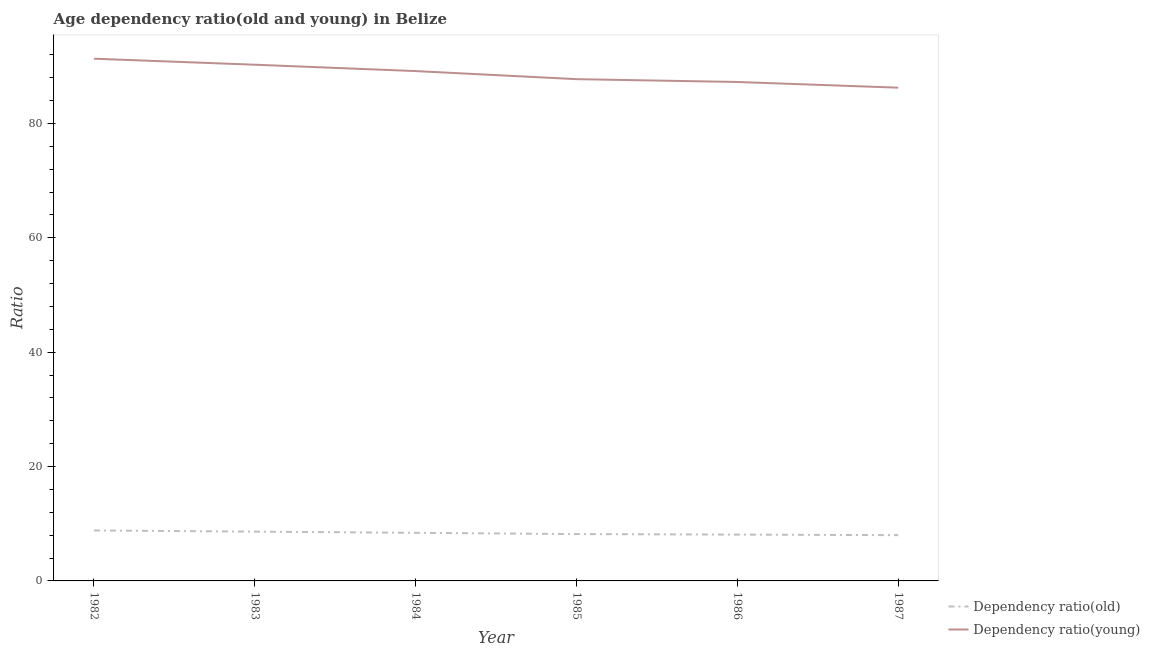How many different coloured lines are there?
Make the answer very short. 2. Does the line corresponding to age dependency ratio(old) intersect with the line corresponding to age dependency ratio(young)?
Offer a terse response. No. Is the number of lines equal to the number of legend labels?
Offer a terse response. Yes. What is the age dependency ratio(young) in 1982?
Give a very brief answer. 91.31. Across all years, what is the maximum age dependency ratio(old)?
Your response must be concise. 8.82. Across all years, what is the minimum age dependency ratio(young)?
Provide a short and direct response. 86.25. What is the total age dependency ratio(old) in the graph?
Provide a succinct answer. 50.15. What is the difference between the age dependency ratio(young) in 1982 and that in 1984?
Offer a terse response. 2.17. What is the difference between the age dependency ratio(young) in 1986 and the age dependency ratio(old) in 1987?
Ensure brevity in your answer.  79.23. What is the average age dependency ratio(young) per year?
Your answer should be very brief. 88.65. In the year 1982, what is the difference between the age dependency ratio(old) and age dependency ratio(young)?
Give a very brief answer. -82.49. What is the ratio of the age dependency ratio(young) in 1983 to that in 1985?
Offer a very short reply. 1.03. Is the age dependency ratio(young) in 1983 less than that in 1986?
Your answer should be very brief. No. Is the difference between the age dependency ratio(old) in 1983 and 1986 greater than the difference between the age dependency ratio(young) in 1983 and 1986?
Ensure brevity in your answer.  No. What is the difference between the highest and the second highest age dependency ratio(old)?
Ensure brevity in your answer.  0.2. What is the difference between the highest and the lowest age dependency ratio(old)?
Offer a terse response. 0.82. In how many years, is the age dependency ratio(young) greater than the average age dependency ratio(young) taken over all years?
Your answer should be compact. 3. How many lines are there?
Provide a succinct answer. 2. Are the values on the major ticks of Y-axis written in scientific E-notation?
Your response must be concise. No. Does the graph contain any zero values?
Provide a succinct answer. No. Where does the legend appear in the graph?
Offer a terse response. Bottom right. How many legend labels are there?
Ensure brevity in your answer.  2. What is the title of the graph?
Keep it short and to the point. Age dependency ratio(old and young) in Belize. What is the label or title of the Y-axis?
Provide a succinct answer. Ratio. What is the Ratio of Dependency ratio(old) in 1982?
Keep it short and to the point. 8.82. What is the Ratio in Dependency ratio(young) in 1982?
Your answer should be very brief. 91.31. What is the Ratio in Dependency ratio(old) in 1983?
Your answer should be very brief. 8.62. What is the Ratio of Dependency ratio(young) in 1983?
Your answer should be compact. 90.26. What is the Ratio of Dependency ratio(old) in 1984?
Your answer should be very brief. 8.41. What is the Ratio of Dependency ratio(young) in 1984?
Your response must be concise. 89.15. What is the Ratio in Dependency ratio(old) in 1985?
Keep it short and to the point. 8.19. What is the Ratio of Dependency ratio(young) in 1985?
Give a very brief answer. 87.73. What is the Ratio of Dependency ratio(old) in 1986?
Your response must be concise. 8.1. What is the Ratio in Dependency ratio(young) in 1986?
Provide a short and direct response. 87.24. What is the Ratio in Dependency ratio(old) in 1987?
Provide a short and direct response. 8. What is the Ratio of Dependency ratio(young) in 1987?
Keep it short and to the point. 86.25. Across all years, what is the maximum Ratio of Dependency ratio(old)?
Offer a terse response. 8.82. Across all years, what is the maximum Ratio of Dependency ratio(young)?
Offer a terse response. 91.31. Across all years, what is the minimum Ratio of Dependency ratio(old)?
Make the answer very short. 8. Across all years, what is the minimum Ratio in Dependency ratio(young)?
Offer a very short reply. 86.25. What is the total Ratio in Dependency ratio(old) in the graph?
Offer a very short reply. 50.15. What is the total Ratio in Dependency ratio(young) in the graph?
Your answer should be compact. 531.93. What is the difference between the Ratio of Dependency ratio(old) in 1982 and that in 1983?
Your response must be concise. 0.2. What is the difference between the Ratio of Dependency ratio(young) in 1982 and that in 1983?
Make the answer very short. 1.05. What is the difference between the Ratio in Dependency ratio(old) in 1982 and that in 1984?
Ensure brevity in your answer.  0.41. What is the difference between the Ratio in Dependency ratio(young) in 1982 and that in 1984?
Give a very brief answer. 2.17. What is the difference between the Ratio of Dependency ratio(old) in 1982 and that in 1985?
Your answer should be very brief. 0.63. What is the difference between the Ratio in Dependency ratio(young) in 1982 and that in 1985?
Give a very brief answer. 3.58. What is the difference between the Ratio of Dependency ratio(old) in 1982 and that in 1986?
Offer a terse response. 0.72. What is the difference between the Ratio in Dependency ratio(young) in 1982 and that in 1986?
Provide a succinct answer. 4.07. What is the difference between the Ratio of Dependency ratio(old) in 1982 and that in 1987?
Provide a short and direct response. 0.82. What is the difference between the Ratio of Dependency ratio(young) in 1982 and that in 1987?
Your answer should be very brief. 5.07. What is the difference between the Ratio of Dependency ratio(old) in 1983 and that in 1984?
Give a very brief answer. 0.21. What is the difference between the Ratio of Dependency ratio(young) in 1983 and that in 1984?
Provide a short and direct response. 1.11. What is the difference between the Ratio of Dependency ratio(old) in 1983 and that in 1985?
Give a very brief answer. 0.43. What is the difference between the Ratio in Dependency ratio(young) in 1983 and that in 1985?
Make the answer very short. 2.52. What is the difference between the Ratio of Dependency ratio(old) in 1983 and that in 1986?
Provide a short and direct response. 0.52. What is the difference between the Ratio in Dependency ratio(young) in 1983 and that in 1986?
Ensure brevity in your answer.  3.02. What is the difference between the Ratio of Dependency ratio(old) in 1983 and that in 1987?
Provide a succinct answer. 0.62. What is the difference between the Ratio of Dependency ratio(young) in 1983 and that in 1987?
Keep it short and to the point. 4.01. What is the difference between the Ratio of Dependency ratio(old) in 1984 and that in 1985?
Ensure brevity in your answer.  0.22. What is the difference between the Ratio in Dependency ratio(young) in 1984 and that in 1985?
Give a very brief answer. 1.41. What is the difference between the Ratio in Dependency ratio(old) in 1984 and that in 1986?
Make the answer very short. 0.31. What is the difference between the Ratio of Dependency ratio(young) in 1984 and that in 1986?
Provide a short and direct response. 1.91. What is the difference between the Ratio of Dependency ratio(old) in 1984 and that in 1987?
Provide a short and direct response. 0.41. What is the difference between the Ratio of Dependency ratio(young) in 1984 and that in 1987?
Provide a short and direct response. 2.9. What is the difference between the Ratio in Dependency ratio(old) in 1985 and that in 1986?
Keep it short and to the point. 0.09. What is the difference between the Ratio in Dependency ratio(young) in 1985 and that in 1986?
Ensure brevity in your answer.  0.5. What is the difference between the Ratio of Dependency ratio(old) in 1985 and that in 1987?
Make the answer very short. 0.19. What is the difference between the Ratio of Dependency ratio(young) in 1985 and that in 1987?
Keep it short and to the point. 1.49. What is the difference between the Ratio of Dependency ratio(old) in 1986 and that in 1987?
Your answer should be very brief. 0.1. What is the difference between the Ratio in Dependency ratio(old) in 1982 and the Ratio in Dependency ratio(young) in 1983?
Offer a terse response. -81.44. What is the difference between the Ratio in Dependency ratio(old) in 1982 and the Ratio in Dependency ratio(young) in 1984?
Your answer should be compact. -80.33. What is the difference between the Ratio of Dependency ratio(old) in 1982 and the Ratio of Dependency ratio(young) in 1985?
Provide a succinct answer. -78.91. What is the difference between the Ratio of Dependency ratio(old) in 1982 and the Ratio of Dependency ratio(young) in 1986?
Keep it short and to the point. -78.42. What is the difference between the Ratio in Dependency ratio(old) in 1982 and the Ratio in Dependency ratio(young) in 1987?
Provide a short and direct response. -77.43. What is the difference between the Ratio of Dependency ratio(old) in 1983 and the Ratio of Dependency ratio(young) in 1984?
Keep it short and to the point. -80.52. What is the difference between the Ratio of Dependency ratio(old) in 1983 and the Ratio of Dependency ratio(young) in 1985?
Your answer should be very brief. -79.11. What is the difference between the Ratio of Dependency ratio(old) in 1983 and the Ratio of Dependency ratio(young) in 1986?
Provide a succinct answer. -78.62. What is the difference between the Ratio in Dependency ratio(old) in 1983 and the Ratio in Dependency ratio(young) in 1987?
Offer a terse response. -77.62. What is the difference between the Ratio of Dependency ratio(old) in 1984 and the Ratio of Dependency ratio(young) in 1985?
Keep it short and to the point. -79.32. What is the difference between the Ratio in Dependency ratio(old) in 1984 and the Ratio in Dependency ratio(young) in 1986?
Keep it short and to the point. -78.83. What is the difference between the Ratio of Dependency ratio(old) in 1984 and the Ratio of Dependency ratio(young) in 1987?
Your answer should be compact. -77.84. What is the difference between the Ratio of Dependency ratio(old) in 1985 and the Ratio of Dependency ratio(young) in 1986?
Your response must be concise. -79.04. What is the difference between the Ratio of Dependency ratio(old) in 1985 and the Ratio of Dependency ratio(young) in 1987?
Offer a very short reply. -78.05. What is the difference between the Ratio of Dependency ratio(old) in 1986 and the Ratio of Dependency ratio(young) in 1987?
Your answer should be compact. -78.15. What is the average Ratio of Dependency ratio(old) per year?
Offer a very short reply. 8.36. What is the average Ratio in Dependency ratio(young) per year?
Your answer should be compact. 88.65. In the year 1982, what is the difference between the Ratio of Dependency ratio(old) and Ratio of Dependency ratio(young)?
Your response must be concise. -82.49. In the year 1983, what is the difference between the Ratio of Dependency ratio(old) and Ratio of Dependency ratio(young)?
Provide a succinct answer. -81.64. In the year 1984, what is the difference between the Ratio of Dependency ratio(old) and Ratio of Dependency ratio(young)?
Your answer should be compact. -80.74. In the year 1985, what is the difference between the Ratio of Dependency ratio(old) and Ratio of Dependency ratio(young)?
Ensure brevity in your answer.  -79.54. In the year 1986, what is the difference between the Ratio of Dependency ratio(old) and Ratio of Dependency ratio(young)?
Your answer should be compact. -79.14. In the year 1987, what is the difference between the Ratio of Dependency ratio(old) and Ratio of Dependency ratio(young)?
Your answer should be very brief. -78.24. What is the ratio of the Ratio of Dependency ratio(old) in 1982 to that in 1983?
Give a very brief answer. 1.02. What is the ratio of the Ratio of Dependency ratio(young) in 1982 to that in 1983?
Your answer should be compact. 1.01. What is the ratio of the Ratio in Dependency ratio(old) in 1982 to that in 1984?
Make the answer very short. 1.05. What is the ratio of the Ratio of Dependency ratio(young) in 1982 to that in 1984?
Keep it short and to the point. 1.02. What is the ratio of the Ratio in Dependency ratio(old) in 1982 to that in 1985?
Keep it short and to the point. 1.08. What is the ratio of the Ratio in Dependency ratio(young) in 1982 to that in 1985?
Your answer should be compact. 1.04. What is the ratio of the Ratio of Dependency ratio(old) in 1982 to that in 1986?
Your answer should be very brief. 1.09. What is the ratio of the Ratio of Dependency ratio(young) in 1982 to that in 1986?
Provide a short and direct response. 1.05. What is the ratio of the Ratio in Dependency ratio(old) in 1982 to that in 1987?
Provide a succinct answer. 1.1. What is the ratio of the Ratio of Dependency ratio(young) in 1982 to that in 1987?
Keep it short and to the point. 1.06. What is the ratio of the Ratio of Dependency ratio(old) in 1983 to that in 1984?
Offer a very short reply. 1.03. What is the ratio of the Ratio in Dependency ratio(young) in 1983 to that in 1984?
Provide a short and direct response. 1.01. What is the ratio of the Ratio in Dependency ratio(old) in 1983 to that in 1985?
Your answer should be very brief. 1.05. What is the ratio of the Ratio in Dependency ratio(young) in 1983 to that in 1985?
Give a very brief answer. 1.03. What is the ratio of the Ratio of Dependency ratio(old) in 1983 to that in 1986?
Give a very brief answer. 1.06. What is the ratio of the Ratio of Dependency ratio(young) in 1983 to that in 1986?
Your response must be concise. 1.03. What is the ratio of the Ratio in Dependency ratio(old) in 1983 to that in 1987?
Your answer should be very brief. 1.08. What is the ratio of the Ratio in Dependency ratio(young) in 1983 to that in 1987?
Give a very brief answer. 1.05. What is the ratio of the Ratio of Dependency ratio(old) in 1984 to that in 1985?
Provide a succinct answer. 1.03. What is the ratio of the Ratio in Dependency ratio(young) in 1984 to that in 1985?
Your response must be concise. 1.02. What is the ratio of the Ratio in Dependency ratio(old) in 1984 to that in 1986?
Your answer should be very brief. 1.04. What is the ratio of the Ratio in Dependency ratio(young) in 1984 to that in 1986?
Your answer should be very brief. 1.02. What is the ratio of the Ratio in Dependency ratio(old) in 1984 to that in 1987?
Offer a terse response. 1.05. What is the ratio of the Ratio of Dependency ratio(young) in 1984 to that in 1987?
Offer a very short reply. 1.03. What is the ratio of the Ratio of Dependency ratio(old) in 1985 to that in 1986?
Keep it short and to the point. 1.01. What is the ratio of the Ratio in Dependency ratio(young) in 1985 to that in 1986?
Offer a terse response. 1.01. What is the ratio of the Ratio in Dependency ratio(old) in 1985 to that in 1987?
Your answer should be compact. 1.02. What is the ratio of the Ratio of Dependency ratio(young) in 1985 to that in 1987?
Keep it short and to the point. 1.02. What is the ratio of the Ratio in Dependency ratio(old) in 1986 to that in 1987?
Keep it short and to the point. 1.01. What is the ratio of the Ratio of Dependency ratio(young) in 1986 to that in 1987?
Provide a succinct answer. 1.01. What is the difference between the highest and the second highest Ratio in Dependency ratio(old)?
Make the answer very short. 0.2. What is the difference between the highest and the second highest Ratio of Dependency ratio(young)?
Ensure brevity in your answer.  1.05. What is the difference between the highest and the lowest Ratio of Dependency ratio(old)?
Your answer should be compact. 0.82. What is the difference between the highest and the lowest Ratio of Dependency ratio(young)?
Provide a short and direct response. 5.07. 